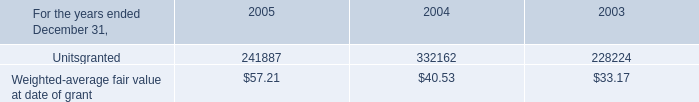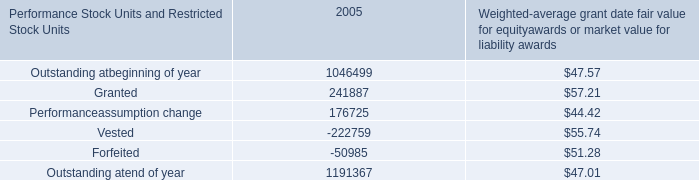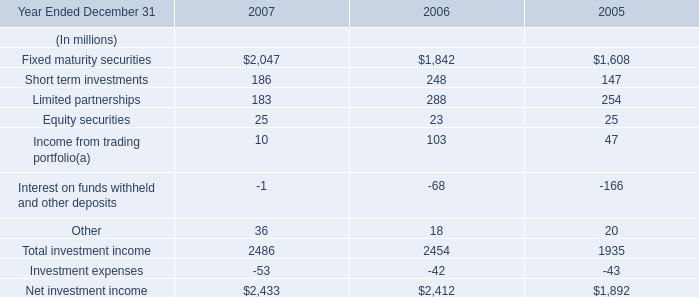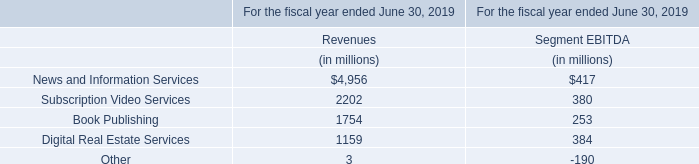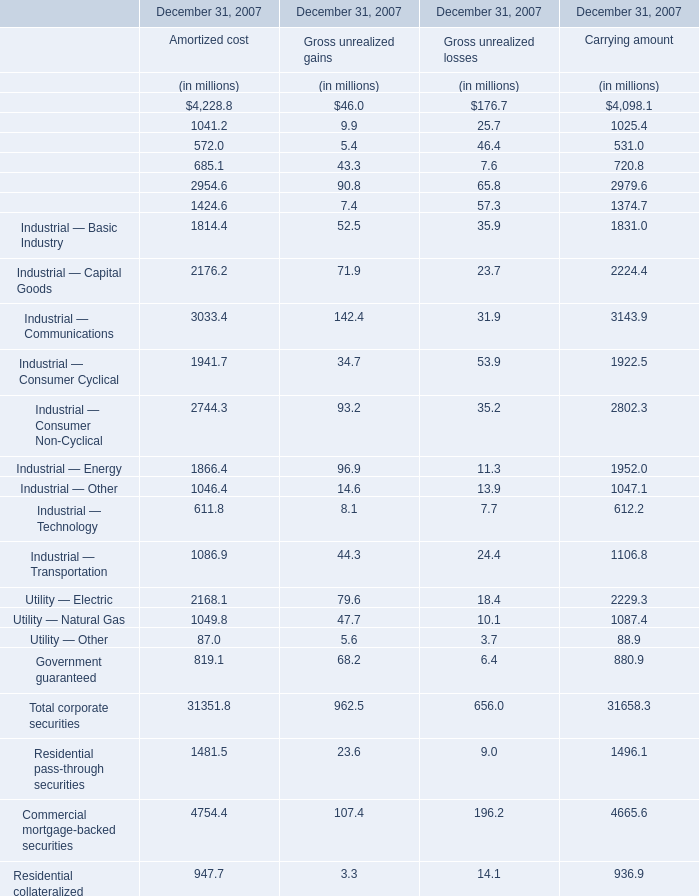What is the average amount of Industrial — Energy of December 31, 2007 Amortized cost, and Net investment income of 2007 ? 
Computations: ((1866.4 + 2433.0) / 2)
Answer: 2149.7. What is the sum of Finance — Insurance of December 31, 2007 Amortized cost, and Fixed maturity securities of 2006 ? 
Computations: (2954.6 + 1842.0)
Answer: 4796.6. 